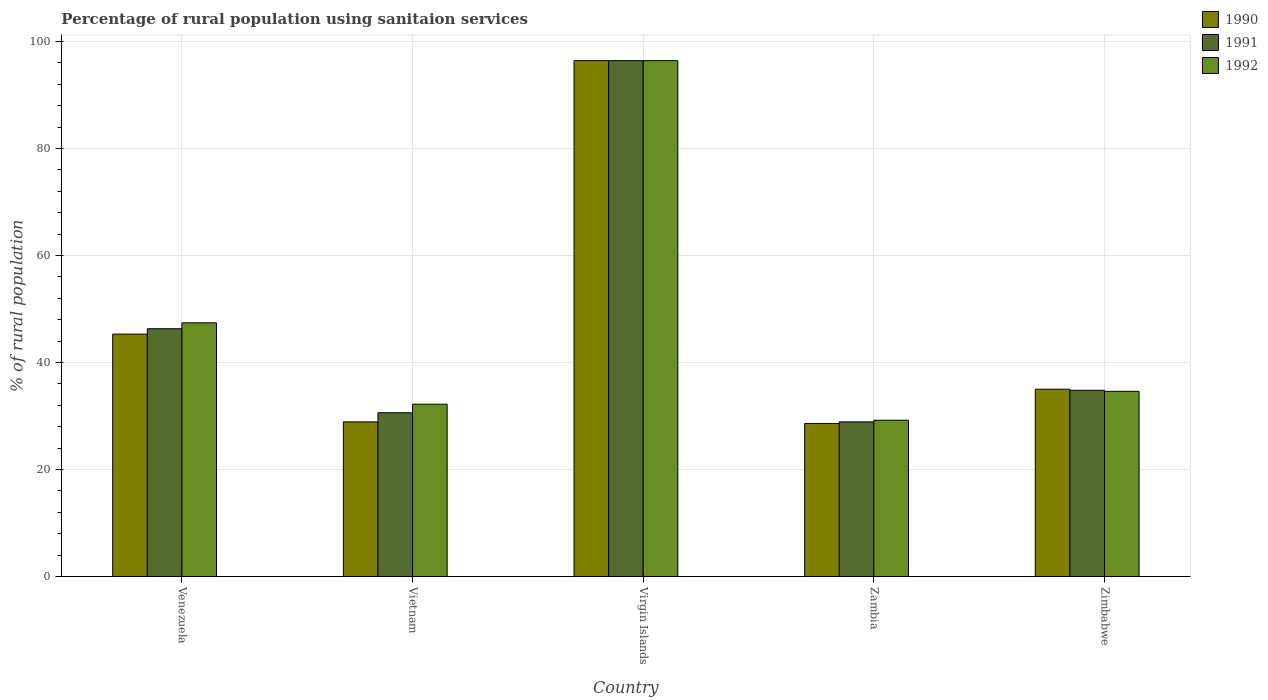How many different coloured bars are there?
Your answer should be compact. 3. Are the number of bars on each tick of the X-axis equal?
Ensure brevity in your answer.  Yes. How many bars are there on the 4th tick from the left?
Your answer should be very brief. 3. How many bars are there on the 4th tick from the right?
Your answer should be very brief. 3. What is the label of the 1st group of bars from the left?
Your response must be concise. Venezuela. In how many cases, is the number of bars for a given country not equal to the number of legend labels?
Make the answer very short. 0. What is the percentage of rural population using sanitaion services in 1992 in Zambia?
Offer a very short reply. 29.2. Across all countries, what is the maximum percentage of rural population using sanitaion services in 1990?
Offer a terse response. 96.4. Across all countries, what is the minimum percentage of rural population using sanitaion services in 1992?
Offer a very short reply. 29.2. In which country was the percentage of rural population using sanitaion services in 1991 maximum?
Your response must be concise. Virgin Islands. In which country was the percentage of rural population using sanitaion services in 1991 minimum?
Provide a succinct answer. Zambia. What is the total percentage of rural population using sanitaion services in 1991 in the graph?
Your answer should be compact. 237. What is the difference between the percentage of rural population using sanitaion services in 1992 in Venezuela and that in Zimbabwe?
Offer a very short reply. 12.8. What is the difference between the percentage of rural population using sanitaion services in 1991 in Vietnam and the percentage of rural population using sanitaion services in 1990 in Zimbabwe?
Your answer should be compact. -4.4. What is the average percentage of rural population using sanitaion services in 1990 per country?
Provide a succinct answer. 46.84. What is the difference between the percentage of rural population using sanitaion services of/in 1990 and percentage of rural population using sanitaion services of/in 1992 in Zimbabwe?
Make the answer very short. 0.4. In how many countries, is the percentage of rural population using sanitaion services in 1990 greater than 92 %?
Give a very brief answer. 1. What is the ratio of the percentage of rural population using sanitaion services in 1991 in Venezuela to that in Virgin Islands?
Your answer should be very brief. 0.48. What is the difference between the highest and the second highest percentage of rural population using sanitaion services in 1990?
Your response must be concise. 61.4. What is the difference between the highest and the lowest percentage of rural population using sanitaion services in 1991?
Provide a succinct answer. 67.5. Is the sum of the percentage of rural population using sanitaion services in 1991 in Virgin Islands and Zambia greater than the maximum percentage of rural population using sanitaion services in 1990 across all countries?
Provide a succinct answer. Yes. What does the 3rd bar from the right in Virgin Islands represents?
Ensure brevity in your answer.  1990. Is it the case that in every country, the sum of the percentage of rural population using sanitaion services in 1991 and percentage of rural population using sanitaion services in 1990 is greater than the percentage of rural population using sanitaion services in 1992?
Give a very brief answer. Yes. Are all the bars in the graph horizontal?
Provide a short and direct response. No. How many countries are there in the graph?
Offer a very short reply. 5. What is the title of the graph?
Provide a succinct answer. Percentage of rural population using sanitaion services. Does "1983" appear as one of the legend labels in the graph?
Provide a short and direct response. No. What is the label or title of the X-axis?
Your answer should be compact. Country. What is the label or title of the Y-axis?
Ensure brevity in your answer.  % of rural population. What is the % of rural population of 1990 in Venezuela?
Make the answer very short. 45.3. What is the % of rural population in 1991 in Venezuela?
Your answer should be very brief. 46.3. What is the % of rural population in 1992 in Venezuela?
Your answer should be compact. 47.4. What is the % of rural population in 1990 in Vietnam?
Keep it short and to the point. 28.9. What is the % of rural population in 1991 in Vietnam?
Your answer should be compact. 30.6. What is the % of rural population of 1992 in Vietnam?
Provide a short and direct response. 32.2. What is the % of rural population of 1990 in Virgin Islands?
Offer a very short reply. 96.4. What is the % of rural population of 1991 in Virgin Islands?
Offer a terse response. 96.4. What is the % of rural population of 1992 in Virgin Islands?
Provide a short and direct response. 96.4. What is the % of rural population of 1990 in Zambia?
Ensure brevity in your answer.  28.6. What is the % of rural population in 1991 in Zambia?
Your answer should be compact. 28.9. What is the % of rural population in 1992 in Zambia?
Offer a very short reply. 29.2. What is the % of rural population in 1990 in Zimbabwe?
Provide a short and direct response. 35. What is the % of rural population in 1991 in Zimbabwe?
Ensure brevity in your answer.  34.8. What is the % of rural population in 1992 in Zimbabwe?
Your answer should be compact. 34.6. Across all countries, what is the maximum % of rural population in 1990?
Provide a short and direct response. 96.4. Across all countries, what is the maximum % of rural population in 1991?
Your response must be concise. 96.4. Across all countries, what is the maximum % of rural population in 1992?
Your response must be concise. 96.4. Across all countries, what is the minimum % of rural population of 1990?
Your answer should be compact. 28.6. Across all countries, what is the minimum % of rural population of 1991?
Give a very brief answer. 28.9. Across all countries, what is the minimum % of rural population in 1992?
Your answer should be compact. 29.2. What is the total % of rural population in 1990 in the graph?
Offer a very short reply. 234.2. What is the total % of rural population in 1991 in the graph?
Your response must be concise. 237. What is the total % of rural population in 1992 in the graph?
Make the answer very short. 239.8. What is the difference between the % of rural population in 1990 in Venezuela and that in Virgin Islands?
Keep it short and to the point. -51.1. What is the difference between the % of rural population in 1991 in Venezuela and that in Virgin Islands?
Ensure brevity in your answer.  -50.1. What is the difference between the % of rural population in 1992 in Venezuela and that in Virgin Islands?
Give a very brief answer. -49. What is the difference between the % of rural population in 1991 in Venezuela and that in Zambia?
Keep it short and to the point. 17.4. What is the difference between the % of rural population in 1990 in Venezuela and that in Zimbabwe?
Keep it short and to the point. 10.3. What is the difference between the % of rural population in 1990 in Vietnam and that in Virgin Islands?
Your answer should be very brief. -67.5. What is the difference between the % of rural population of 1991 in Vietnam and that in Virgin Islands?
Your response must be concise. -65.8. What is the difference between the % of rural population of 1992 in Vietnam and that in Virgin Islands?
Ensure brevity in your answer.  -64.2. What is the difference between the % of rural population in 1991 in Vietnam and that in Zambia?
Make the answer very short. 1.7. What is the difference between the % of rural population of 1992 in Vietnam and that in Zambia?
Your answer should be compact. 3. What is the difference between the % of rural population of 1990 in Virgin Islands and that in Zambia?
Offer a very short reply. 67.8. What is the difference between the % of rural population of 1991 in Virgin Islands and that in Zambia?
Offer a very short reply. 67.5. What is the difference between the % of rural population of 1992 in Virgin Islands and that in Zambia?
Offer a terse response. 67.2. What is the difference between the % of rural population in 1990 in Virgin Islands and that in Zimbabwe?
Your answer should be very brief. 61.4. What is the difference between the % of rural population in 1991 in Virgin Islands and that in Zimbabwe?
Keep it short and to the point. 61.6. What is the difference between the % of rural population of 1992 in Virgin Islands and that in Zimbabwe?
Your answer should be compact. 61.8. What is the difference between the % of rural population in 1990 in Venezuela and the % of rural population in 1992 in Vietnam?
Give a very brief answer. 13.1. What is the difference between the % of rural population of 1990 in Venezuela and the % of rural population of 1991 in Virgin Islands?
Your answer should be very brief. -51.1. What is the difference between the % of rural population in 1990 in Venezuela and the % of rural population in 1992 in Virgin Islands?
Keep it short and to the point. -51.1. What is the difference between the % of rural population in 1991 in Venezuela and the % of rural population in 1992 in Virgin Islands?
Your response must be concise. -50.1. What is the difference between the % of rural population of 1991 in Venezuela and the % of rural population of 1992 in Zambia?
Provide a succinct answer. 17.1. What is the difference between the % of rural population in 1990 in Venezuela and the % of rural population in 1991 in Zimbabwe?
Make the answer very short. 10.5. What is the difference between the % of rural population of 1990 in Venezuela and the % of rural population of 1992 in Zimbabwe?
Provide a succinct answer. 10.7. What is the difference between the % of rural population of 1991 in Venezuela and the % of rural population of 1992 in Zimbabwe?
Provide a short and direct response. 11.7. What is the difference between the % of rural population of 1990 in Vietnam and the % of rural population of 1991 in Virgin Islands?
Your answer should be very brief. -67.5. What is the difference between the % of rural population of 1990 in Vietnam and the % of rural population of 1992 in Virgin Islands?
Provide a succinct answer. -67.5. What is the difference between the % of rural population in 1991 in Vietnam and the % of rural population in 1992 in Virgin Islands?
Your response must be concise. -65.8. What is the difference between the % of rural population of 1990 in Vietnam and the % of rural population of 1991 in Zambia?
Provide a short and direct response. 0. What is the difference between the % of rural population of 1991 in Vietnam and the % of rural population of 1992 in Zambia?
Give a very brief answer. 1.4. What is the difference between the % of rural population of 1990 in Vietnam and the % of rural population of 1991 in Zimbabwe?
Offer a terse response. -5.9. What is the difference between the % of rural population in 1990 in Vietnam and the % of rural population in 1992 in Zimbabwe?
Keep it short and to the point. -5.7. What is the difference between the % of rural population of 1991 in Vietnam and the % of rural population of 1992 in Zimbabwe?
Your answer should be very brief. -4. What is the difference between the % of rural population of 1990 in Virgin Islands and the % of rural population of 1991 in Zambia?
Ensure brevity in your answer.  67.5. What is the difference between the % of rural population in 1990 in Virgin Islands and the % of rural population in 1992 in Zambia?
Your answer should be very brief. 67.2. What is the difference between the % of rural population of 1991 in Virgin Islands and the % of rural population of 1992 in Zambia?
Ensure brevity in your answer.  67.2. What is the difference between the % of rural population in 1990 in Virgin Islands and the % of rural population in 1991 in Zimbabwe?
Your response must be concise. 61.6. What is the difference between the % of rural population of 1990 in Virgin Islands and the % of rural population of 1992 in Zimbabwe?
Offer a very short reply. 61.8. What is the difference between the % of rural population in 1991 in Virgin Islands and the % of rural population in 1992 in Zimbabwe?
Make the answer very short. 61.8. What is the difference between the % of rural population in 1990 in Zambia and the % of rural population in 1991 in Zimbabwe?
Provide a short and direct response. -6.2. What is the average % of rural population of 1990 per country?
Offer a very short reply. 46.84. What is the average % of rural population in 1991 per country?
Ensure brevity in your answer.  47.4. What is the average % of rural population in 1992 per country?
Offer a terse response. 47.96. What is the difference between the % of rural population of 1990 and % of rural population of 1991 in Venezuela?
Offer a terse response. -1. What is the difference between the % of rural population in 1990 and % of rural population in 1991 in Virgin Islands?
Keep it short and to the point. 0. What is the difference between the % of rural population of 1990 and % of rural population of 1991 in Zambia?
Keep it short and to the point. -0.3. What is the difference between the % of rural population in 1990 and % of rural population in 1992 in Zambia?
Provide a short and direct response. -0.6. What is the difference between the % of rural population in 1990 and % of rural population in 1991 in Zimbabwe?
Your response must be concise. 0.2. What is the ratio of the % of rural population in 1990 in Venezuela to that in Vietnam?
Ensure brevity in your answer.  1.57. What is the ratio of the % of rural population of 1991 in Venezuela to that in Vietnam?
Give a very brief answer. 1.51. What is the ratio of the % of rural population in 1992 in Venezuela to that in Vietnam?
Offer a terse response. 1.47. What is the ratio of the % of rural population in 1990 in Venezuela to that in Virgin Islands?
Your answer should be compact. 0.47. What is the ratio of the % of rural population of 1991 in Venezuela to that in Virgin Islands?
Give a very brief answer. 0.48. What is the ratio of the % of rural population of 1992 in Venezuela to that in Virgin Islands?
Your response must be concise. 0.49. What is the ratio of the % of rural population in 1990 in Venezuela to that in Zambia?
Offer a terse response. 1.58. What is the ratio of the % of rural population in 1991 in Venezuela to that in Zambia?
Make the answer very short. 1.6. What is the ratio of the % of rural population of 1992 in Venezuela to that in Zambia?
Your response must be concise. 1.62. What is the ratio of the % of rural population of 1990 in Venezuela to that in Zimbabwe?
Provide a short and direct response. 1.29. What is the ratio of the % of rural population of 1991 in Venezuela to that in Zimbabwe?
Ensure brevity in your answer.  1.33. What is the ratio of the % of rural population in 1992 in Venezuela to that in Zimbabwe?
Your answer should be very brief. 1.37. What is the ratio of the % of rural population in 1990 in Vietnam to that in Virgin Islands?
Give a very brief answer. 0.3. What is the ratio of the % of rural population of 1991 in Vietnam to that in Virgin Islands?
Give a very brief answer. 0.32. What is the ratio of the % of rural population of 1992 in Vietnam to that in Virgin Islands?
Your response must be concise. 0.33. What is the ratio of the % of rural population of 1990 in Vietnam to that in Zambia?
Keep it short and to the point. 1.01. What is the ratio of the % of rural population of 1991 in Vietnam to that in Zambia?
Provide a succinct answer. 1.06. What is the ratio of the % of rural population of 1992 in Vietnam to that in Zambia?
Keep it short and to the point. 1.1. What is the ratio of the % of rural population in 1990 in Vietnam to that in Zimbabwe?
Give a very brief answer. 0.83. What is the ratio of the % of rural population in 1991 in Vietnam to that in Zimbabwe?
Your response must be concise. 0.88. What is the ratio of the % of rural population in 1992 in Vietnam to that in Zimbabwe?
Your answer should be compact. 0.93. What is the ratio of the % of rural population of 1990 in Virgin Islands to that in Zambia?
Ensure brevity in your answer.  3.37. What is the ratio of the % of rural population of 1991 in Virgin Islands to that in Zambia?
Offer a terse response. 3.34. What is the ratio of the % of rural population in 1992 in Virgin Islands to that in Zambia?
Your response must be concise. 3.3. What is the ratio of the % of rural population in 1990 in Virgin Islands to that in Zimbabwe?
Your response must be concise. 2.75. What is the ratio of the % of rural population of 1991 in Virgin Islands to that in Zimbabwe?
Make the answer very short. 2.77. What is the ratio of the % of rural population of 1992 in Virgin Islands to that in Zimbabwe?
Make the answer very short. 2.79. What is the ratio of the % of rural population in 1990 in Zambia to that in Zimbabwe?
Provide a succinct answer. 0.82. What is the ratio of the % of rural population of 1991 in Zambia to that in Zimbabwe?
Give a very brief answer. 0.83. What is the ratio of the % of rural population in 1992 in Zambia to that in Zimbabwe?
Offer a very short reply. 0.84. What is the difference between the highest and the second highest % of rural population in 1990?
Your answer should be compact. 51.1. What is the difference between the highest and the second highest % of rural population in 1991?
Make the answer very short. 50.1. What is the difference between the highest and the second highest % of rural population of 1992?
Offer a very short reply. 49. What is the difference between the highest and the lowest % of rural population in 1990?
Your answer should be compact. 67.8. What is the difference between the highest and the lowest % of rural population of 1991?
Your answer should be very brief. 67.5. What is the difference between the highest and the lowest % of rural population of 1992?
Give a very brief answer. 67.2. 